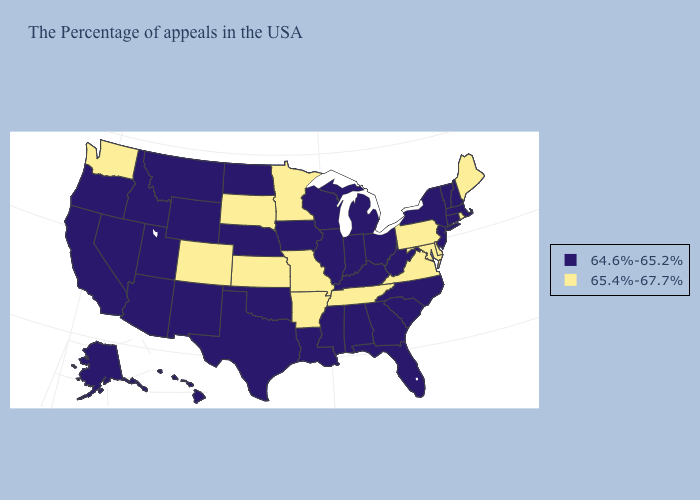What is the highest value in the Northeast ?
Be succinct. 65.4%-67.7%. What is the value of North Dakota?
Be succinct. 64.6%-65.2%. Does West Virginia have a lower value than Missouri?
Answer briefly. Yes. Does Nevada have the highest value in the USA?
Give a very brief answer. No. Name the states that have a value in the range 64.6%-65.2%?
Give a very brief answer. Massachusetts, New Hampshire, Vermont, Connecticut, New York, New Jersey, North Carolina, South Carolina, West Virginia, Ohio, Florida, Georgia, Michigan, Kentucky, Indiana, Alabama, Wisconsin, Illinois, Mississippi, Louisiana, Iowa, Nebraska, Oklahoma, Texas, North Dakota, Wyoming, New Mexico, Utah, Montana, Arizona, Idaho, Nevada, California, Oregon, Alaska, Hawaii. What is the value of Montana?
Give a very brief answer. 64.6%-65.2%. Name the states that have a value in the range 65.4%-67.7%?
Give a very brief answer. Maine, Rhode Island, Delaware, Maryland, Pennsylvania, Virginia, Tennessee, Missouri, Arkansas, Minnesota, Kansas, South Dakota, Colorado, Washington. Which states have the lowest value in the USA?
Quick response, please. Massachusetts, New Hampshire, Vermont, Connecticut, New York, New Jersey, North Carolina, South Carolina, West Virginia, Ohio, Florida, Georgia, Michigan, Kentucky, Indiana, Alabama, Wisconsin, Illinois, Mississippi, Louisiana, Iowa, Nebraska, Oklahoma, Texas, North Dakota, Wyoming, New Mexico, Utah, Montana, Arizona, Idaho, Nevada, California, Oregon, Alaska, Hawaii. Among the states that border New York , does Pennsylvania have the lowest value?
Short answer required. No. Does Virginia have the same value as Maryland?
Quick response, please. Yes. Does Michigan have a higher value than Delaware?
Keep it brief. No. Which states have the highest value in the USA?
Short answer required. Maine, Rhode Island, Delaware, Maryland, Pennsylvania, Virginia, Tennessee, Missouri, Arkansas, Minnesota, Kansas, South Dakota, Colorado, Washington. What is the value of Arkansas?
Answer briefly. 65.4%-67.7%. Name the states that have a value in the range 65.4%-67.7%?
Write a very short answer. Maine, Rhode Island, Delaware, Maryland, Pennsylvania, Virginia, Tennessee, Missouri, Arkansas, Minnesota, Kansas, South Dakota, Colorado, Washington. 